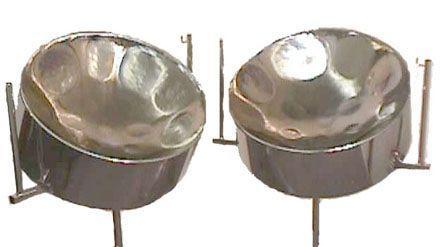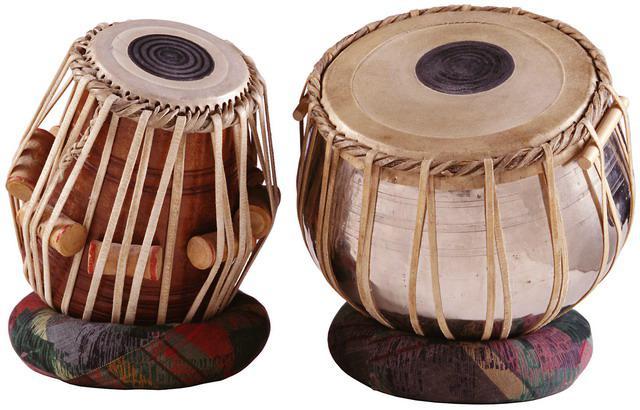The first image is the image on the left, the second image is the image on the right. Assess this claim about the two images: "a set of drums have a dark circle on top, and leather strips around the drum holding wooden dowels". Correct or not? Answer yes or no. Yes. The first image is the image on the left, the second image is the image on the right. For the images shown, is this caption "One image features a pair of drums wrapped in pale cord, with pillow bases and flat tops with black dots in the center, and the other image is a pair of side-by-side shiny bowl-shaped steel drums." true? Answer yes or no. Yes. 